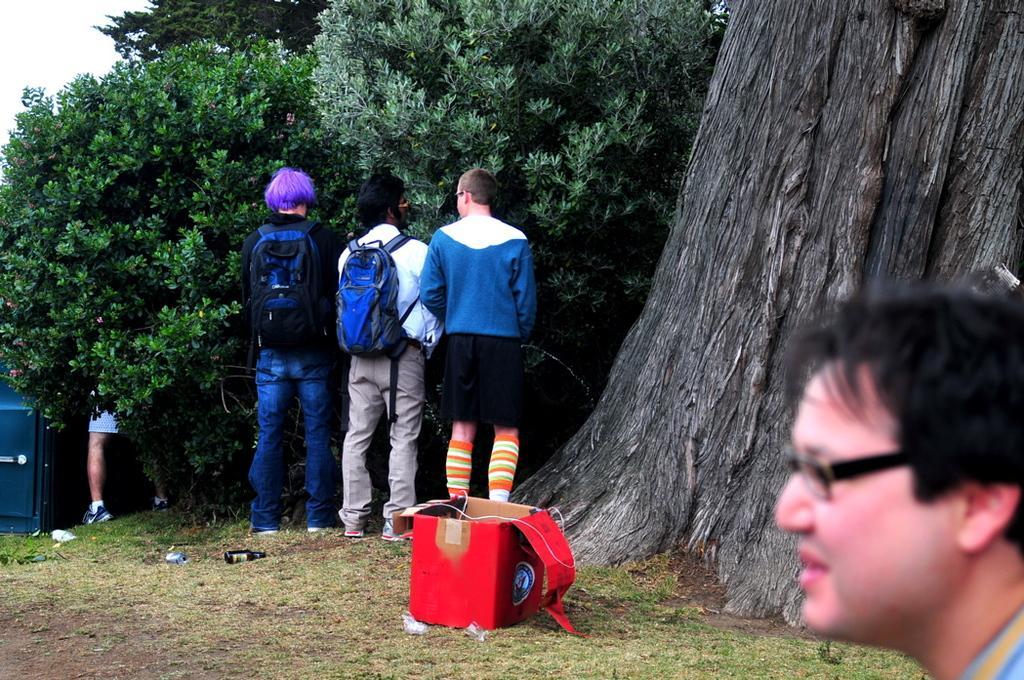How would you summarize this image in a sentence or two? In the foreground of the image we can see three persons standing in the ground ,two persons are wearing bags. In the middle of the image we can see a box placed on the ground. To the right side of the image we can see a person wearing spectacles and in the background we can see group of trees and sky. 